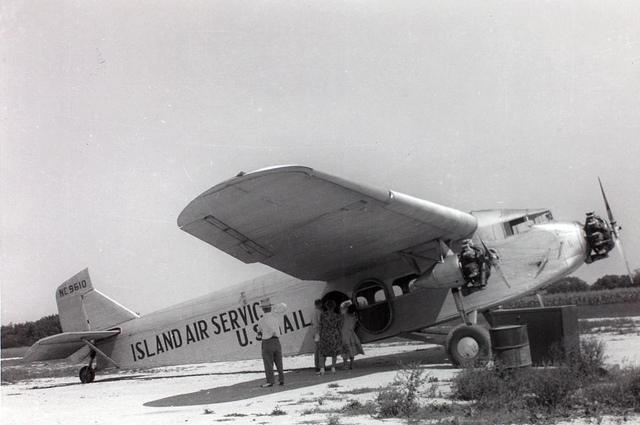What does the plane say?
Answer briefly. Island air service us mail. Is this a vintage plane?
Write a very short answer. Yes. What do they deliver?
Give a very brief answer. Mail. Is the plane on the ground?
Keep it brief. Yes. 